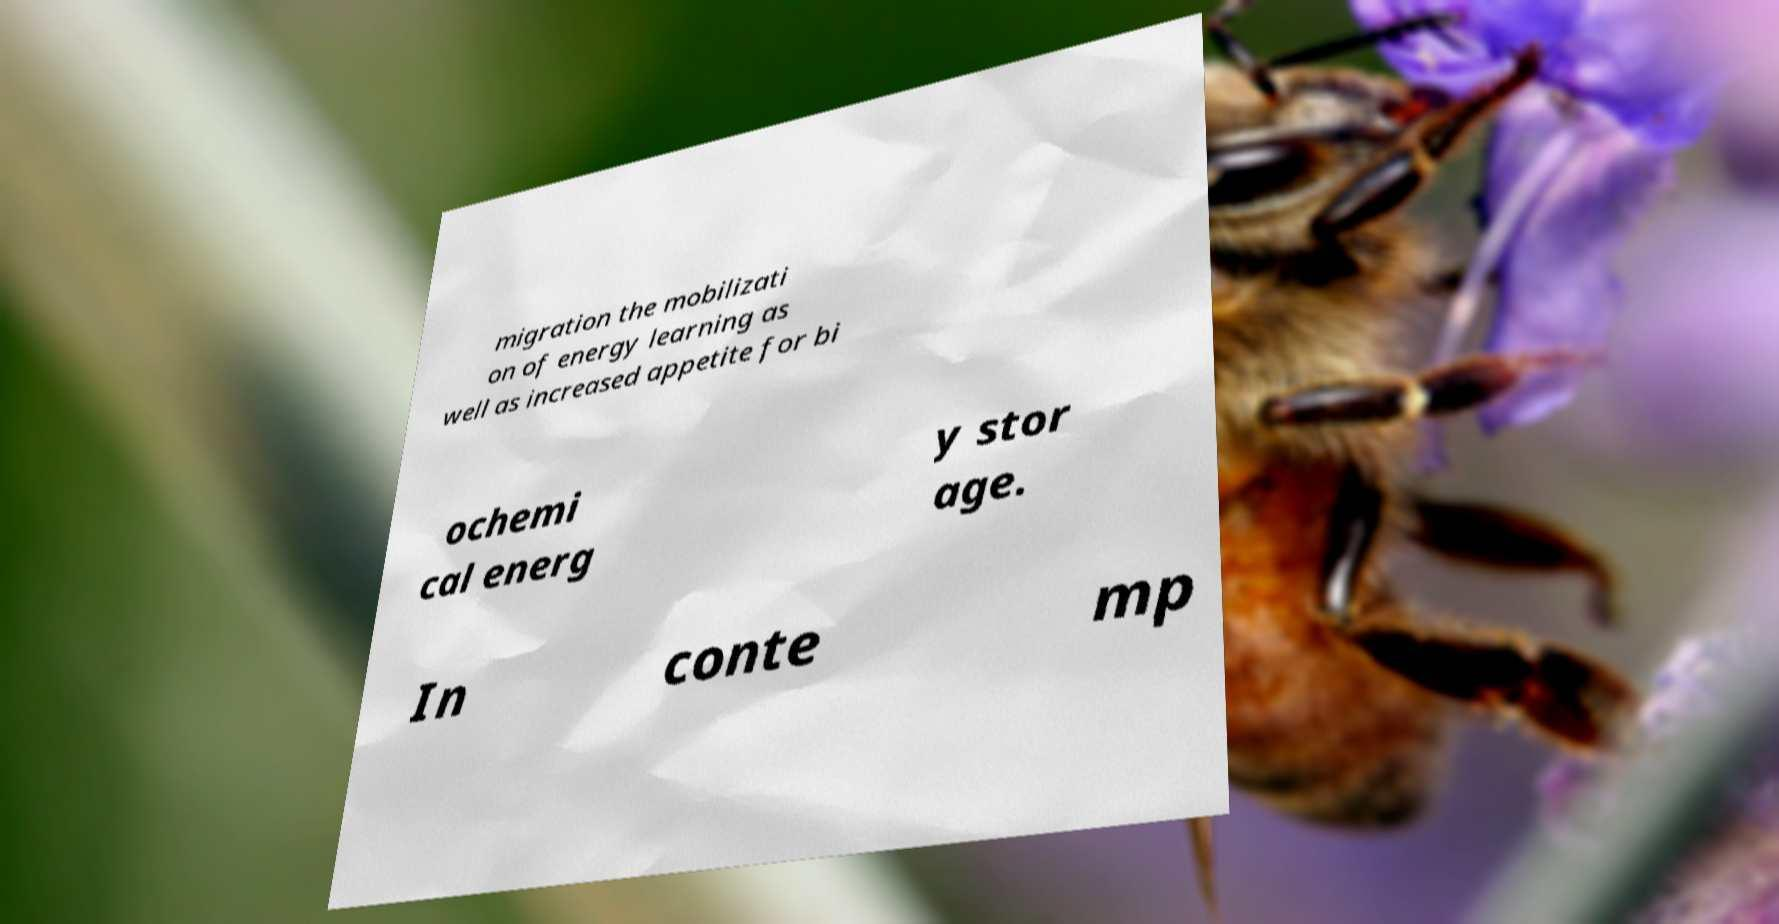What messages or text are displayed in this image? I need them in a readable, typed format. migration the mobilizati on of energy learning as well as increased appetite for bi ochemi cal energ y stor age. In conte mp 